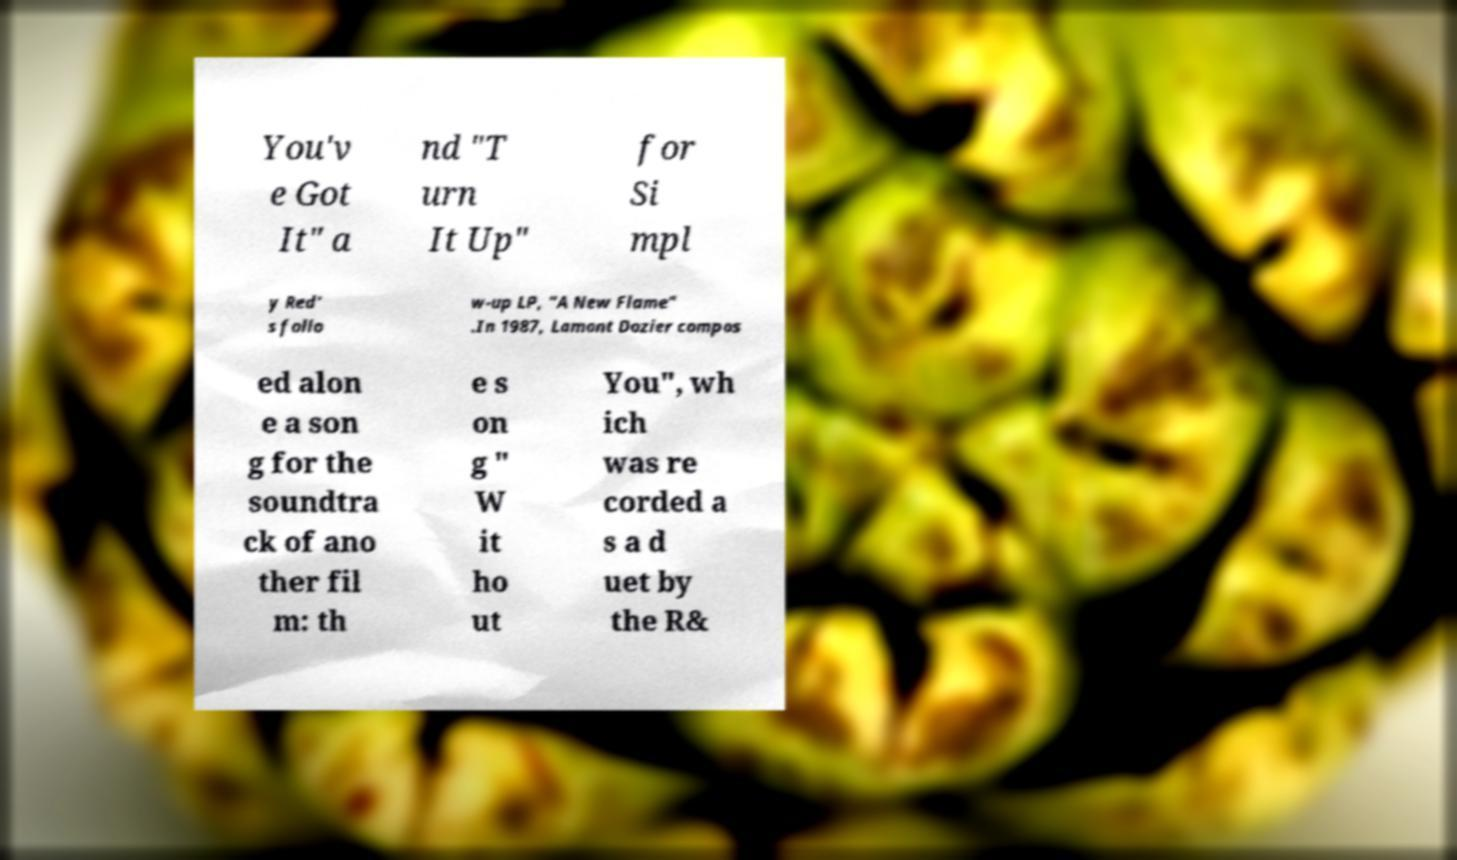Please identify and transcribe the text found in this image. You'v e Got It" a nd "T urn It Up" for Si mpl y Red' s follo w-up LP, "A New Flame" .In 1987, Lamont Dozier compos ed alon e a son g for the soundtra ck of ano ther fil m: th e s on g " W it ho ut You", wh ich was re corded a s a d uet by the R& 